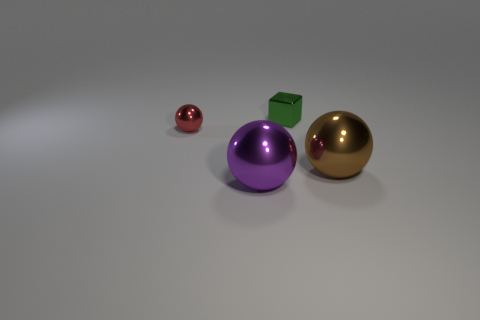Subtract all big metal balls. How many balls are left? 1 Subtract all blocks. How many objects are left? 3 Add 4 brown metallic spheres. How many objects exist? 8 Add 4 tiny green cubes. How many tiny green cubes are left? 5 Add 2 purple matte things. How many purple matte things exist? 2 Subtract 0 cyan spheres. How many objects are left? 4 Subtract all small red cubes. Subtract all brown metal objects. How many objects are left? 3 